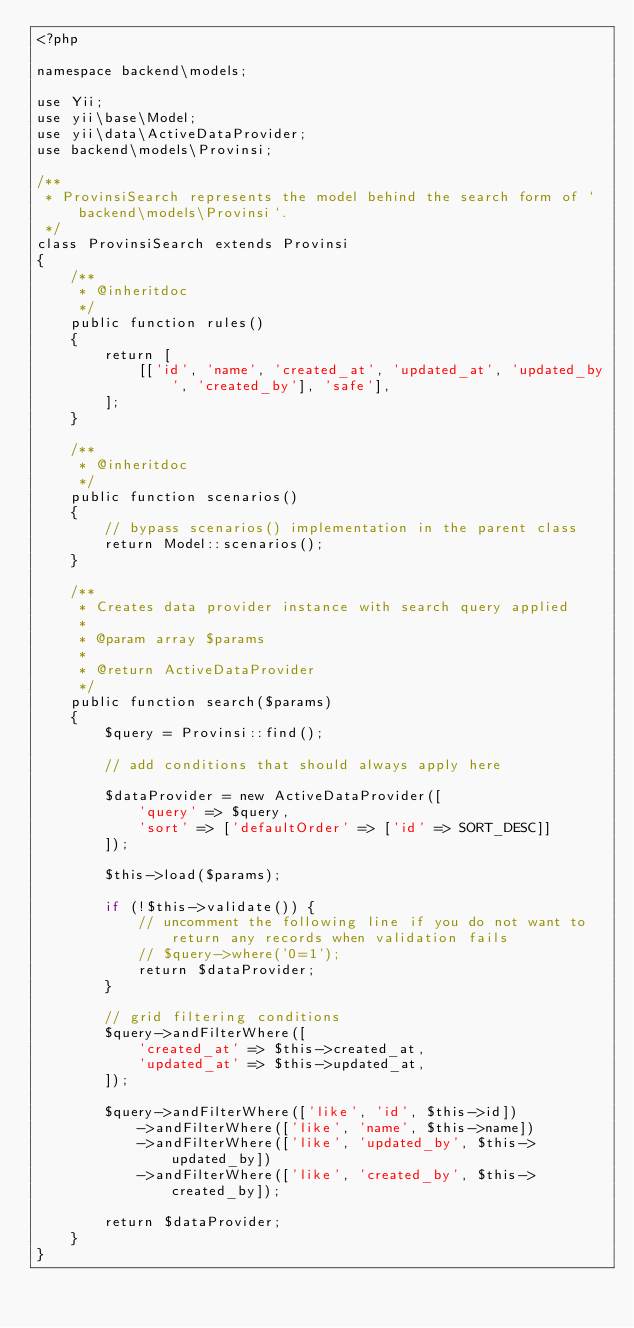Convert code to text. <code><loc_0><loc_0><loc_500><loc_500><_PHP_><?php

namespace backend\models;

use Yii;
use yii\base\Model;
use yii\data\ActiveDataProvider;
use backend\models\Provinsi;

/**
 * ProvinsiSearch represents the model behind the search form of `backend\models\Provinsi`.
 */
class ProvinsiSearch extends Provinsi
{
    /**
     * @inheritdoc
     */
    public function rules()
    {
        return [
            [['id', 'name', 'created_at', 'updated_at', 'updated_by', 'created_by'], 'safe'],
        ];
    }

    /**
     * @inheritdoc
     */
    public function scenarios()
    {
        // bypass scenarios() implementation in the parent class
        return Model::scenarios();
    }

    /**
     * Creates data provider instance with search query applied
     *
     * @param array $params
     *
     * @return ActiveDataProvider
     */
    public function search($params)
    {
        $query = Provinsi::find();

        // add conditions that should always apply here

        $dataProvider = new ActiveDataProvider([
            'query' => $query,
            'sort' => ['defaultOrder' => ['id' => SORT_DESC]]
        ]);

        $this->load($params);

        if (!$this->validate()) {
            // uncomment the following line if you do not want to return any records when validation fails
            // $query->where('0=1');
            return $dataProvider;
        }

        // grid filtering conditions
        $query->andFilterWhere([
            'created_at' => $this->created_at,
            'updated_at' => $this->updated_at,
        ]);

        $query->andFilterWhere(['like', 'id', $this->id])
            ->andFilterWhere(['like', 'name', $this->name])
            ->andFilterWhere(['like', 'updated_by', $this->updated_by])
            ->andFilterWhere(['like', 'created_by', $this->created_by]);

        return $dataProvider;
    }
}
</code> 